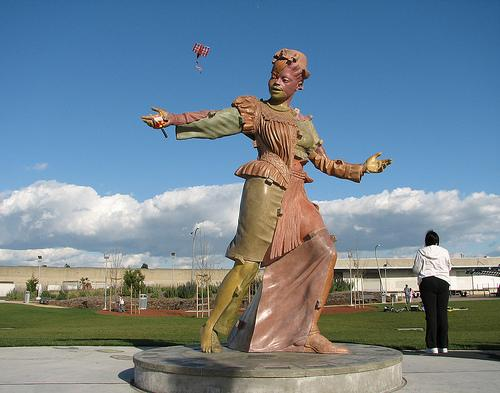Portray the dress and appearance of the woman in the statue. The woman in the statue is dressed in a two-tone dress, predominantly brown with green accents, and is wearing a bonnet. Her hair appears to be styled up under the bonnet. What's the most notable feature on the statue of the woman? The most notable feature of the statue is her dynamic pose with arms spread out, as if in motion, and her gaze directed towards her right hand. What can you tell about the person standing next to the statue? The person standing next to the statue is wearing a white hoodie and white shoes, and is facing away from the camera. Describe the scene above the statue in the image. Above the statue, the sky is clear and blue, with a red kite flying high in the air. Mention any objects the statue is holding and their colors. The statue is holding a red and white striped object in its right hand. Describe the ground and the area beneath the statue. The statue is mounted on a round concrete base, and it casts a shadow on the grey ground. What type of tasks can you perform with this image considering the available information? Tasks such as visual entailment, multiple-choice visual question answering (VQA), product advertisement, and referential expression grounding could be performed with this image. In a few words, describe the location and surroundings of the statue. The statue is located on a round concrete base with a large, low building in the background and a person standing to its right. Briefly describe the sky and the clouds in the image. The sky is clear and blue with a few white clouds scattered throughout. Choose the most accurate description for the statue in the image. The statue is a woman depicted in a dynamic pose with arms spread out, wearing a two-tone brown and green dress with a bonnet, and looking at her right hand. 